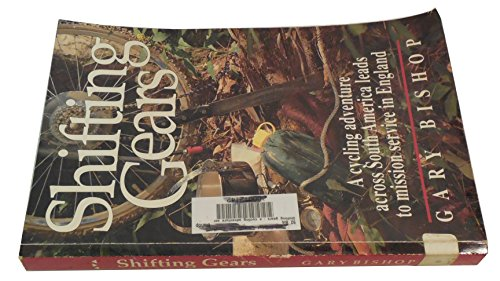Who is the author of this book? The author of the book is Gary Bishop, as clearly stated along with the title on the book cover. 